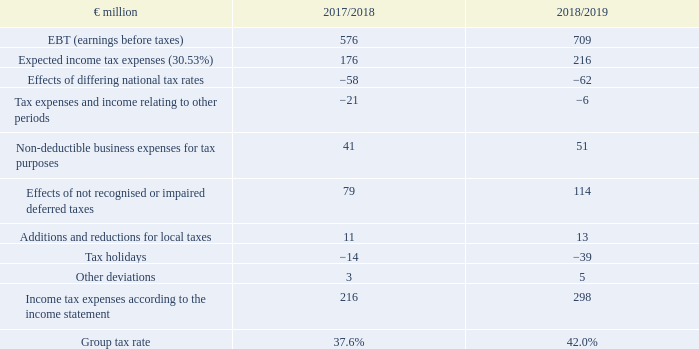Applying the German group tax rate to the reported pre-tax result would result in an income tax expense of €216 million (2017/18: €176 million). The deviation of €81 million (2017/18: €40 million) from the reported tax expense of €298 million (2017/18: €216 million) can be reconciled as follows:
1 Adjustment of previous year according to explanation in notes.
The item ‘effects of differing national tax rates’ includes a deferred tax revenue of €6 million (2017/18: €23 million) from tax rate changes.
Tax expenses and income relating to other periods of the previous year include a repayment of approximately €20 million because of a retrospective change in foreign law in 2018.
Tax holidays for the current year include effects from real estate transactions in the amount of €30 million (2017/18: €2 million).
What does the item ‘effects of differing national tax rates’ include? A deferred tax revenue of €6 million (2017/18: €23 million) from tax rate changes. What would the income tax expense in FY2019 be if the German group tax rate was applied to the reported pre-tax result? €216 million. In which years were the Group tax rate provided in the table? 2017/2018, 2018/2019. In which year was the Group tax rate larger? 42.0%>37.6%
Answer: 2018/2019. What was the change in EBT in 2018/2019 from 2017/2018?
Answer scale should be: million. 709-576
Answer: 133. What was the percentage change in EBT in 2018/2019 from 2017/2018?
Answer scale should be: percent. (709-576)/576
Answer: 23.09. 